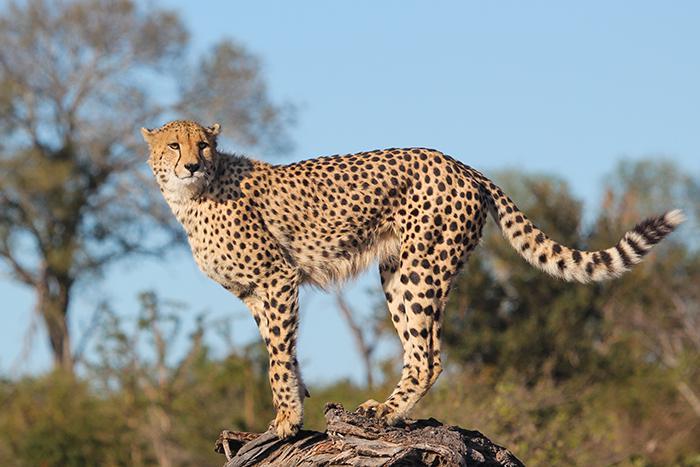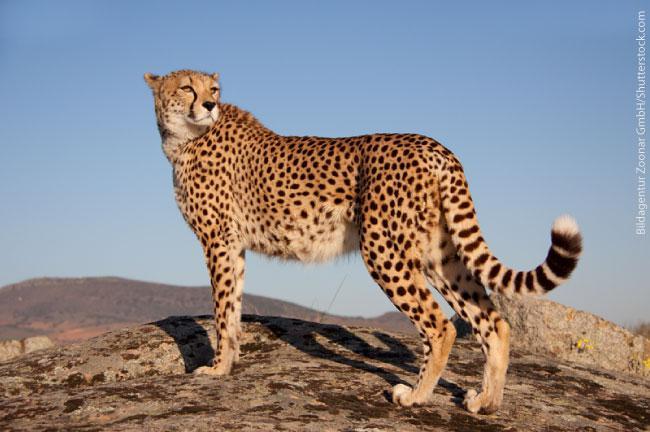The first image is the image on the left, the second image is the image on the right. Evaluate the accuracy of this statement regarding the images: "Cheetahs are alone, without children, and not running.". Is it true? Answer yes or no. Yes. 